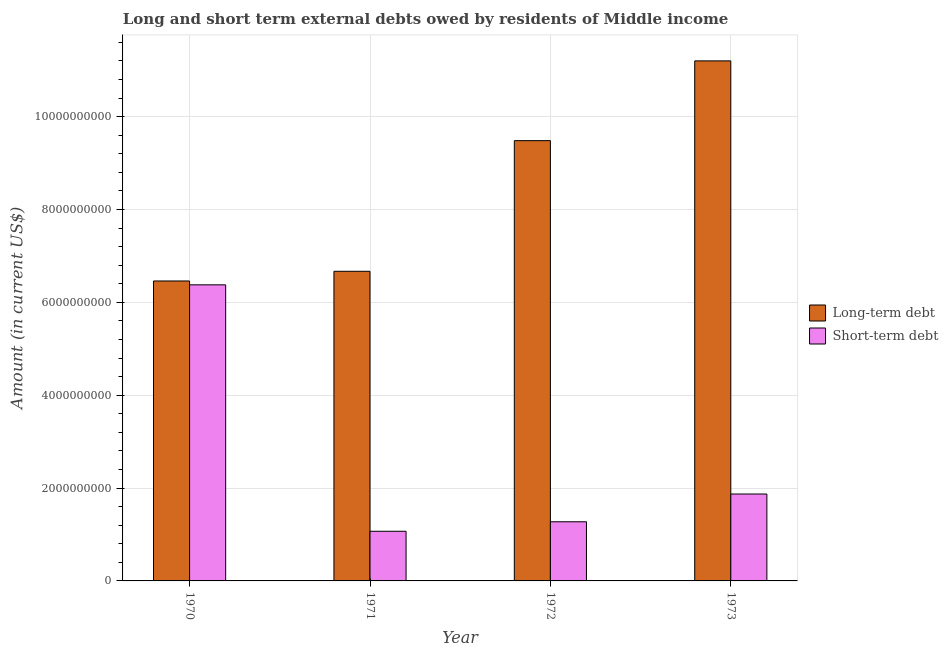How many different coloured bars are there?
Offer a very short reply. 2. How many bars are there on the 2nd tick from the left?
Your answer should be very brief. 2. What is the long-term debts owed by residents in 1972?
Make the answer very short. 9.48e+09. Across all years, what is the maximum short-term debts owed by residents?
Ensure brevity in your answer.  6.38e+09. Across all years, what is the minimum short-term debts owed by residents?
Ensure brevity in your answer.  1.07e+09. In which year was the short-term debts owed by residents maximum?
Your response must be concise. 1970. In which year was the long-term debts owed by residents minimum?
Make the answer very short. 1970. What is the total short-term debts owed by residents in the graph?
Offer a very short reply. 1.06e+1. What is the difference between the long-term debts owed by residents in 1971 and that in 1973?
Your answer should be compact. -4.53e+09. What is the difference between the long-term debts owed by residents in 1972 and the short-term debts owed by residents in 1970?
Offer a terse response. 3.02e+09. What is the average long-term debts owed by residents per year?
Offer a terse response. 8.45e+09. In the year 1970, what is the difference between the short-term debts owed by residents and long-term debts owed by residents?
Your answer should be compact. 0. In how many years, is the long-term debts owed by residents greater than 1600000000 US$?
Your response must be concise. 4. What is the ratio of the long-term debts owed by residents in 1971 to that in 1973?
Your response must be concise. 0.6. Is the long-term debts owed by residents in 1972 less than that in 1973?
Give a very brief answer. Yes. Is the difference between the long-term debts owed by residents in 1970 and 1971 greater than the difference between the short-term debts owed by residents in 1970 and 1971?
Offer a terse response. No. What is the difference between the highest and the second highest long-term debts owed by residents?
Offer a very short reply. 1.72e+09. What is the difference between the highest and the lowest long-term debts owed by residents?
Your answer should be very brief. 4.74e+09. What does the 2nd bar from the left in 1971 represents?
Ensure brevity in your answer.  Short-term debt. What does the 2nd bar from the right in 1970 represents?
Your answer should be very brief. Long-term debt. What is the difference between two consecutive major ticks on the Y-axis?
Give a very brief answer. 2.00e+09. Are the values on the major ticks of Y-axis written in scientific E-notation?
Ensure brevity in your answer.  No. How many legend labels are there?
Make the answer very short. 2. What is the title of the graph?
Your answer should be very brief. Long and short term external debts owed by residents of Middle income. What is the label or title of the Y-axis?
Keep it short and to the point. Amount (in current US$). What is the Amount (in current US$) in Long-term debt in 1970?
Your answer should be very brief. 6.46e+09. What is the Amount (in current US$) in Short-term debt in 1970?
Give a very brief answer. 6.38e+09. What is the Amount (in current US$) of Long-term debt in 1971?
Provide a short and direct response. 6.67e+09. What is the Amount (in current US$) in Short-term debt in 1971?
Provide a succinct answer. 1.07e+09. What is the Amount (in current US$) in Long-term debt in 1972?
Offer a terse response. 9.48e+09. What is the Amount (in current US$) of Short-term debt in 1972?
Give a very brief answer. 1.27e+09. What is the Amount (in current US$) of Long-term debt in 1973?
Provide a short and direct response. 1.12e+1. What is the Amount (in current US$) of Short-term debt in 1973?
Offer a very short reply. 1.87e+09. Across all years, what is the maximum Amount (in current US$) of Long-term debt?
Offer a terse response. 1.12e+1. Across all years, what is the maximum Amount (in current US$) of Short-term debt?
Your answer should be compact. 6.38e+09. Across all years, what is the minimum Amount (in current US$) in Long-term debt?
Make the answer very short. 6.46e+09. Across all years, what is the minimum Amount (in current US$) in Short-term debt?
Make the answer very short. 1.07e+09. What is the total Amount (in current US$) of Long-term debt in the graph?
Give a very brief answer. 3.38e+1. What is the total Amount (in current US$) in Short-term debt in the graph?
Provide a short and direct response. 1.06e+1. What is the difference between the Amount (in current US$) of Long-term debt in 1970 and that in 1971?
Your answer should be very brief. -2.08e+08. What is the difference between the Amount (in current US$) of Short-term debt in 1970 and that in 1971?
Your response must be concise. 5.31e+09. What is the difference between the Amount (in current US$) in Long-term debt in 1970 and that in 1972?
Make the answer very short. -3.02e+09. What is the difference between the Amount (in current US$) in Short-term debt in 1970 and that in 1972?
Your answer should be very brief. 5.10e+09. What is the difference between the Amount (in current US$) of Long-term debt in 1970 and that in 1973?
Make the answer very short. -4.74e+09. What is the difference between the Amount (in current US$) of Short-term debt in 1970 and that in 1973?
Keep it short and to the point. 4.51e+09. What is the difference between the Amount (in current US$) in Long-term debt in 1971 and that in 1972?
Offer a very short reply. -2.81e+09. What is the difference between the Amount (in current US$) of Short-term debt in 1971 and that in 1972?
Offer a very short reply. -2.05e+08. What is the difference between the Amount (in current US$) in Long-term debt in 1971 and that in 1973?
Make the answer very short. -4.53e+09. What is the difference between the Amount (in current US$) in Short-term debt in 1971 and that in 1973?
Provide a short and direct response. -8.03e+08. What is the difference between the Amount (in current US$) in Long-term debt in 1972 and that in 1973?
Your answer should be very brief. -1.72e+09. What is the difference between the Amount (in current US$) of Short-term debt in 1972 and that in 1973?
Keep it short and to the point. -5.98e+08. What is the difference between the Amount (in current US$) in Long-term debt in 1970 and the Amount (in current US$) in Short-term debt in 1971?
Provide a short and direct response. 5.39e+09. What is the difference between the Amount (in current US$) of Long-term debt in 1970 and the Amount (in current US$) of Short-term debt in 1972?
Your answer should be compact. 5.19e+09. What is the difference between the Amount (in current US$) in Long-term debt in 1970 and the Amount (in current US$) in Short-term debt in 1973?
Offer a very short reply. 4.59e+09. What is the difference between the Amount (in current US$) of Long-term debt in 1971 and the Amount (in current US$) of Short-term debt in 1972?
Offer a terse response. 5.40e+09. What is the difference between the Amount (in current US$) in Long-term debt in 1971 and the Amount (in current US$) in Short-term debt in 1973?
Make the answer very short. 4.80e+09. What is the difference between the Amount (in current US$) of Long-term debt in 1972 and the Amount (in current US$) of Short-term debt in 1973?
Make the answer very short. 7.61e+09. What is the average Amount (in current US$) in Long-term debt per year?
Ensure brevity in your answer.  8.45e+09. What is the average Amount (in current US$) of Short-term debt per year?
Your answer should be compact. 2.65e+09. In the year 1970, what is the difference between the Amount (in current US$) in Long-term debt and Amount (in current US$) in Short-term debt?
Provide a short and direct response. 8.34e+07. In the year 1971, what is the difference between the Amount (in current US$) in Long-term debt and Amount (in current US$) in Short-term debt?
Your answer should be very brief. 5.60e+09. In the year 1972, what is the difference between the Amount (in current US$) of Long-term debt and Amount (in current US$) of Short-term debt?
Your response must be concise. 8.21e+09. In the year 1973, what is the difference between the Amount (in current US$) of Long-term debt and Amount (in current US$) of Short-term debt?
Make the answer very short. 9.33e+09. What is the ratio of the Amount (in current US$) in Long-term debt in 1970 to that in 1971?
Your answer should be compact. 0.97. What is the ratio of the Amount (in current US$) of Short-term debt in 1970 to that in 1971?
Your response must be concise. 5.96. What is the ratio of the Amount (in current US$) in Long-term debt in 1970 to that in 1972?
Your answer should be very brief. 0.68. What is the ratio of the Amount (in current US$) in Short-term debt in 1970 to that in 1972?
Your response must be concise. 5.01. What is the ratio of the Amount (in current US$) in Long-term debt in 1970 to that in 1973?
Offer a terse response. 0.58. What is the ratio of the Amount (in current US$) in Short-term debt in 1970 to that in 1973?
Provide a short and direct response. 3.41. What is the ratio of the Amount (in current US$) in Long-term debt in 1971 to that in 1972?
Offer a very short reply. 0.7. What is the ratio of the Amount (in current US$) in Short-term debt in 1971 to that in 1972?
Offer a very short reply. 0.84. What is the ratio of the Amount (in current US$) in Long-term debt in 1971 to that in 1973?
Offer a terse response. 0.6. What is the ratio of the Amount (in current US$) of Short-term debt in 1971 to that in 1973?
Your answer should be very brief. 0.57. What is the ratio of the Amount (in current US$) in Long-term debt in 1972 to that in 1973?
Keep it short and to the point. 0.85. What is the ratio of the Amount (in current US$) in Short-term debt in 1972 to that in 1973?
Give a very brief answer. 0.68. What is the difference between the highest and the second highest Amount (in current US$) in Long-term debt?
Your answer should be very brief. 1.72e+09. What is the difference between the highest and the second highest Amount (in current US$) of Short-term debt?
Make the answer very short. 4.51e+09. What is the difference between the highest and the lowest Amount (in current US$) in Long-term debt?
Offer a very short reply. 4.74e+09. What is the difference between the highest and the lowest Amount (in current US$) of Short-term debt?
Keep it short and to the point. 5.31e+09. 